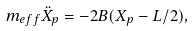<formula> <loc_0><loc_0><loc_500><loc_500>m _ { e f f } \ddot { X } _ { p } = - 2 B ( X _ { p } - L / 2 ) ,</formula> 